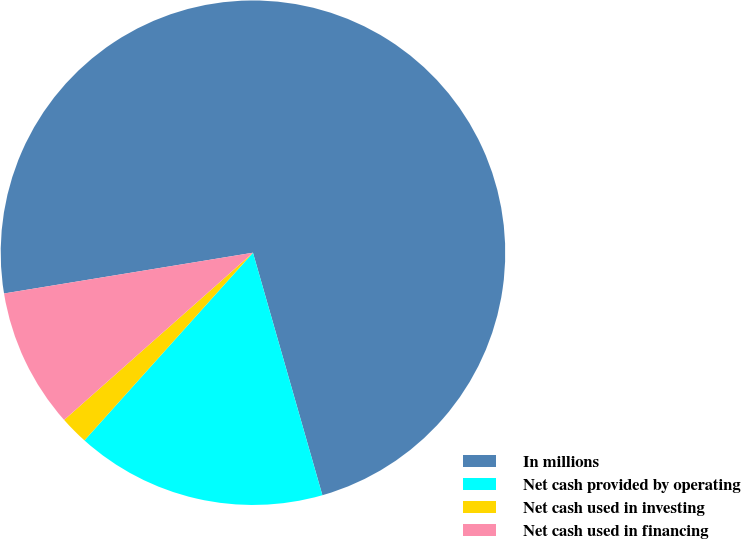Convert chart to OTSL. <chart><loc_0><loc_0><loc_500><loc_500><pie_chart><fcel>In millions<fcel>Net cash provided by operating<fcel>Net cash used in investing<fcel>Net cash used in financing<nl><fcel>73.14%<fcel>16.08%<fcel>1.82%<fcel>8.95%<nl></chart> 